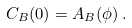<formula> <loc_0><loc_0><loc_500><loc_500>C _ { B } ( 0 ) = A _ { B } ( \phi ) \, .</formula> 